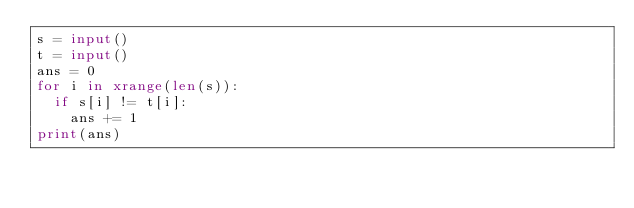Convert code to text. <code><loc_0><loc_0><loc_500><loc_500><_Python_>s = input()
t = input()
ans = 0
for i in xrange(len(s)):
  if s[i] != t[i]:
    ans += 1
print(ans)</code> 